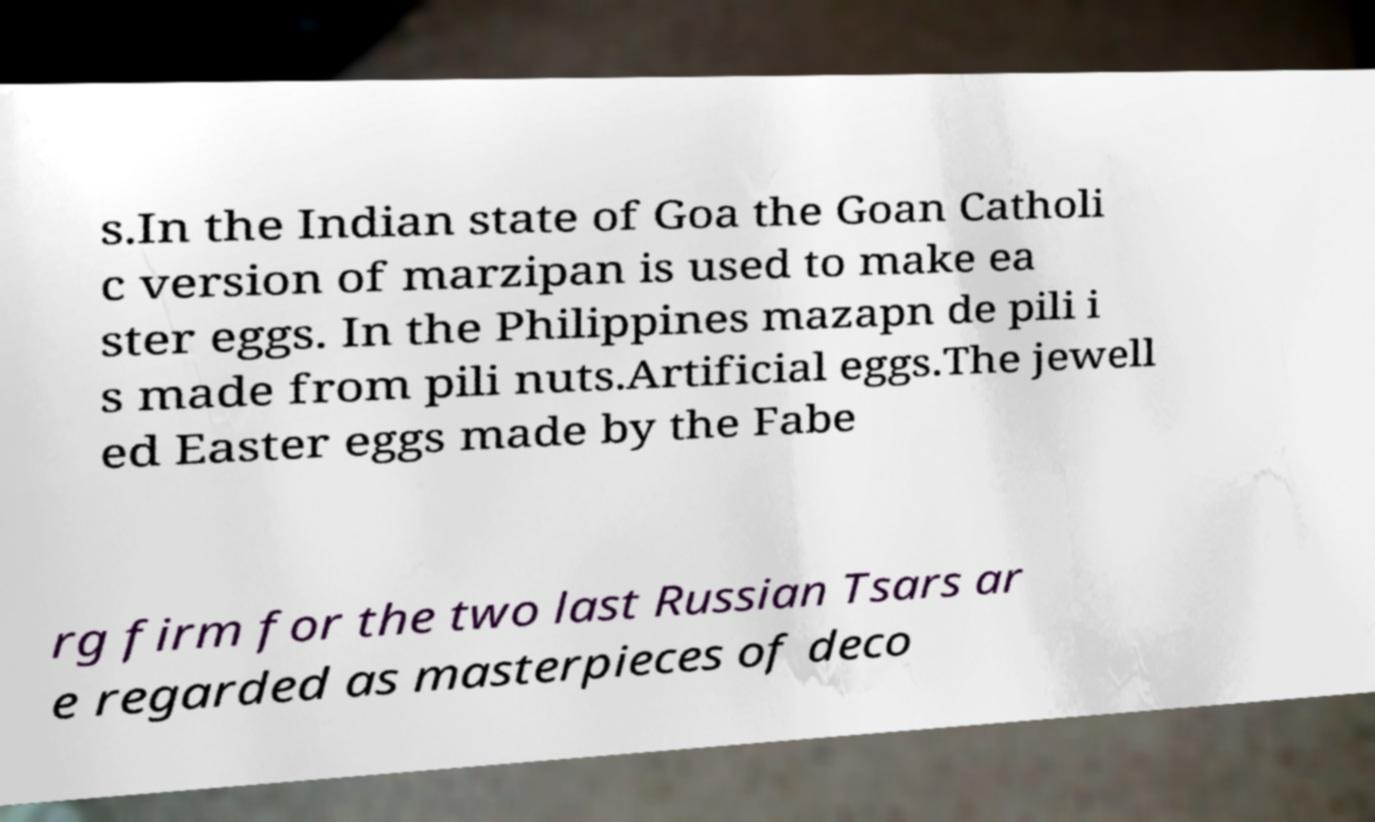Could you extract and type out the text from this image? s.In the Indian state of Goa the Goan Catholi c version of marzipan is used to make ea ster eggs. In the Philippines mazapn de pili i s made from pili nuts.Artificial eggs.The jewell ed Easter eggs made by the Fabe rg firm for the two last Russian Tsars ar e regarded as masterpieces of deco 